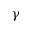Convert formula to latex. <formula><loc_0><loc_0><loc_500><loc_500>\gamma</formula> 